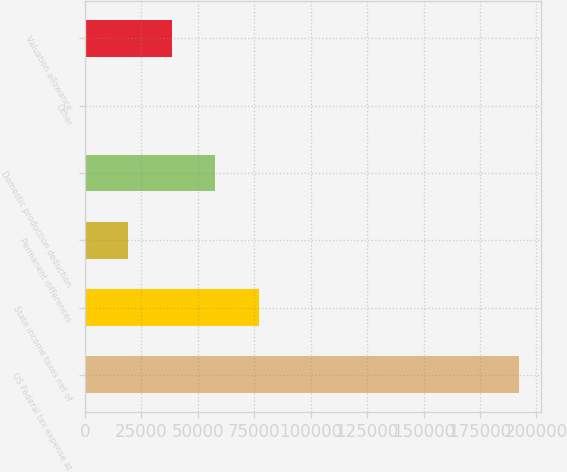Convert chart to OTSL. <chart><loc_0><loc_0><loc_500><loc_500><bar_chart><fcel>US Federal tax expense at<fcel>State income taxes net of<fcel>Permanent differences<fcel>Domestic production deduction<fcel>Other<fcel>Valuation allowance<nl><fcel>192204<fcel>76903.8<fcel>19253.7<fcel>57687.1<fcel>37<fcel>38470.4<nl></chart> 